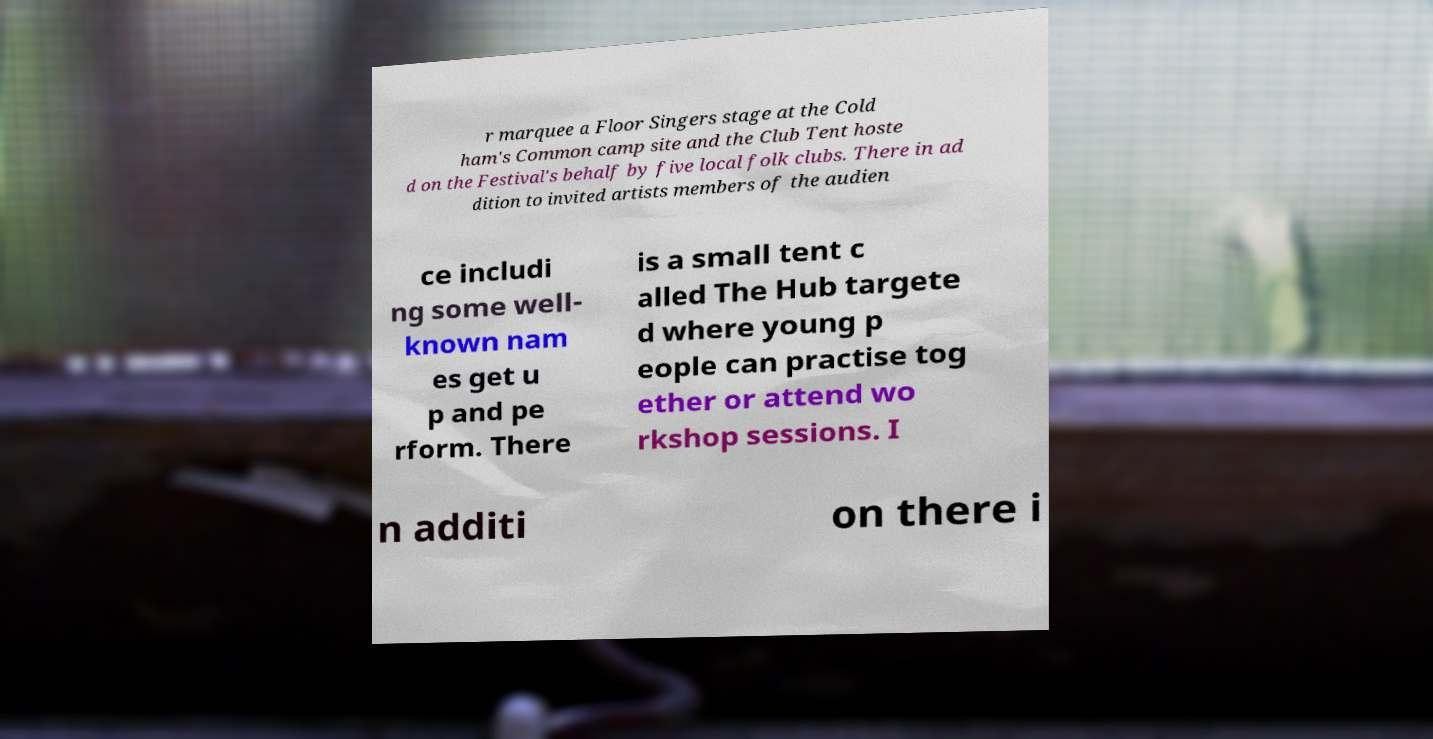For documentation purposes, I need the text within this image transcribed. Could you provide that? r marquee a Floor Singers stage at the Cold ham's Common camp site and the Club Tent hoste d on the Festival's behalf by five local folk clubs. There in ad dition to invited artists members of the audien ce includi ng some well- known nam es get u p and pe rform. There is a small tent c alled The Hub targete d where young p eople can practise tog ether or attend wo rkshop sessions. I n additi on there i 